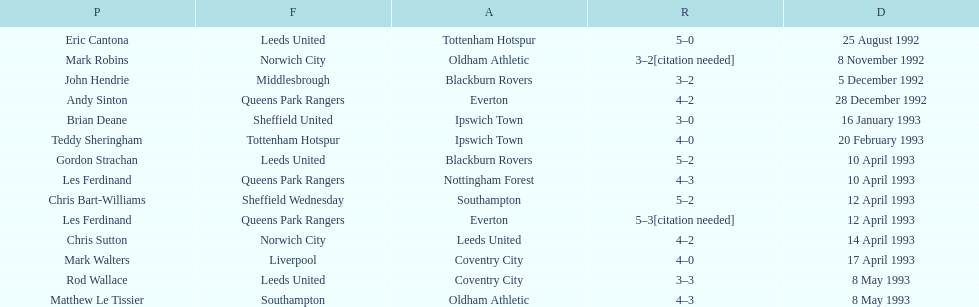I'm looking to parse the entire table for insights. Could you assist me with that? {'header': ['P', 'F', 'A', 'R', 'D'], 'rows': [['Eric Cantona', 'Leeds United', 'Tottenham Hotspur', '5–0', '25 August 1992'], ['Mark Robins', 'Norwich City', 'Oldham Athletic', '3–2[citation needed]', '8 November 1992'], ['John Hendrie', 'Middlesbrough', 'Blackburn Rovers', '3–2', '5 December 1992'], ['Andy Sinton', 'Queens Park Rangers', 'Everton', '4–2', '28 December 1992'], ['Brian Deane', 'Sheffield United', 'Ipswich Town', '3–0', '16 January 1993'], ['Teddy Sheringham', 'Tottenham Hotspur', 'Ipswich Town', '4–0', '20 February 1993'], ['Gordon Strachan', 'Leeds United', 'Blackburn Rovers', '5–2', '10 April 1993'], ['Les Ferdinand', 'Queens Park Rangers', 'Nottingham Forest', '4–3', '10 April 1993'], ['Chris Bart-Williams', 'Sheffield Wednesday', 'Southampton', '5–2', '12 April 1993'], ['Les Ferdinand', 'Queens Park Rangers', 'Everton', '5–3[citation needed]', '12 April 1993'], ['Chris Sutton', 'Norwich City', 'Leeds United', '4–2', '14 April 1993'], ['Mark Walters', 'Liverpool', 'Coventry City', '4–0', '17 April 1993'], ['Rod Wallace', 'Leeds United', 'Coventry City', '3–3', '8 May 1993'], ['Matthew Le Tissier', 'Southampton', 'Oldham Athletic', '4–3', '8 May 1993']]} Southampton played on may 8th, 1993, who was their opponent? Oldham Athletic. 